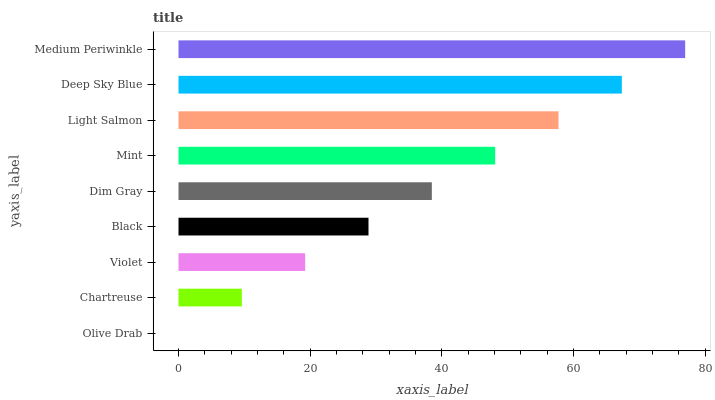Is Olive Drab the minimum?
Answer yes or no. Yes. Is Medium Periwinkle the maximum?
Answer yes or no. Yes. Is Chartreuse the minimum?
Answer yes or no. No. Is Chartreuse the maximum?
Answer yes or no. No. Is Chartreuse greater than Olive Drab?
Answer yes or no. Yes. Is Olive Drab less than Chartreuse?
Answer yes or no. Yes. Is Olive Drab greater than Chartreuse?
Answer yes or no. No. Is Chartreuse less than Olive Drab?
Answer yes or no. No. Is Dim Gray the high median?
Answer yes or no. Yes. Is Dim Gray the low median?
Answer yes or no. Yes. Is Mint the high median?
Answer yes or no. No. Is Olive Drab the low median?
Answer yes or no. No. 